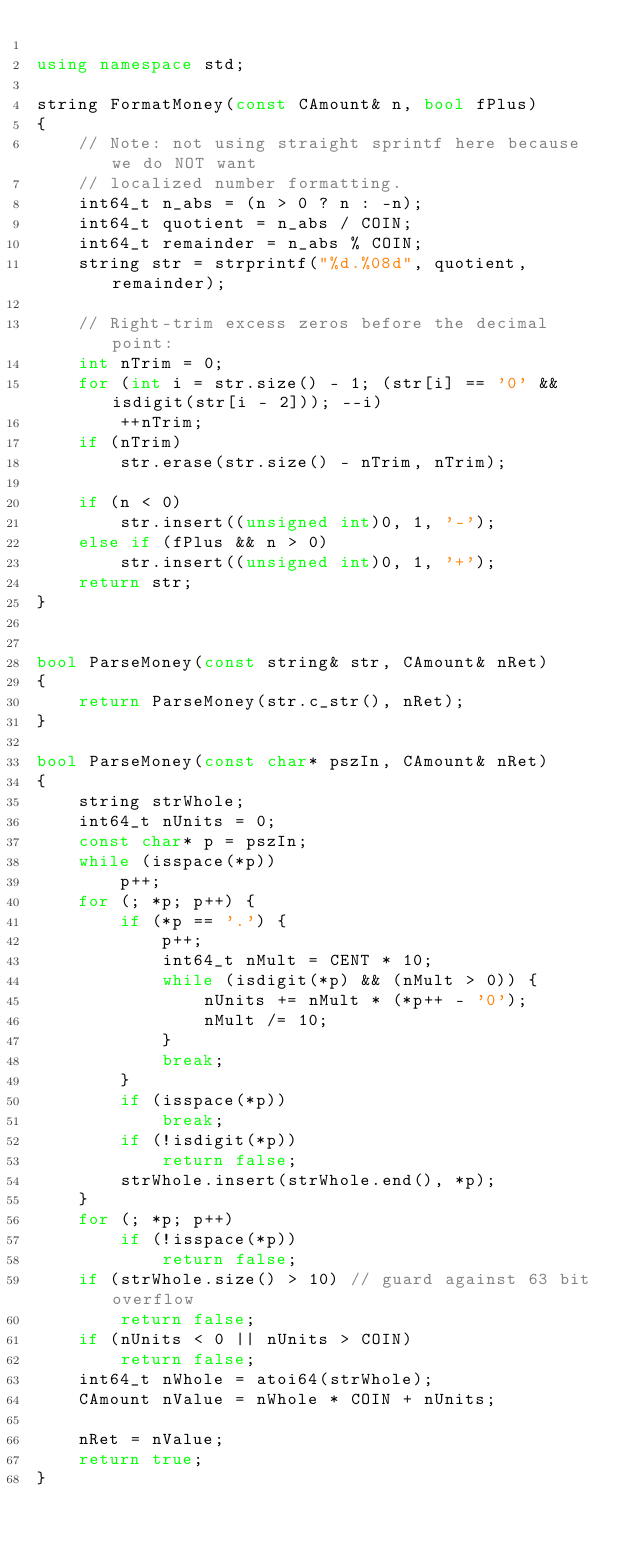<code> <loc_0><loc_0><loc_500><loc_500><_C++_>
using namespace std;

string FormatMoney(const CAmount& n, bool fPlus)
{
    // Note: not using straight sprintf here because we do NOT want
    // localized number formatting.
    int64_t n_abs = (n > 0 ? n : -n);
    int64_t quotient = n_abs / COIN;
    int64_t remainder = n_abs % COIN;
    string str = strprintf("%d.%08d", quotient, remainder);

    // Right-trim excess zeros before the decimal point:
    int nTrim = 0;
    for (int i = str.size() - 1; (str[i] == '0' && isdigit(str[i - 2])); --i)
        ++nTrim;
    if (nTrim)
        str.erase(str.size() - nTrim, nTrim);

    if (n < 0)
        str.insert((unsigned int)0, 1, '-');
    else if (fPlus && n > 0)
        str.insert((unsigned int)0, 1, '+');
    return str;
}


bool ParseMoney(const string& str, CAmount& nRet)
{
    return ParseMoney(str.c_str(), nRet);
}

bool ParseMoney(const char* pszIn, CAmount& nRet)
{
    string strWhole;
    int64_t nUnits = 0;
    const char* p = pszIn;
    while (isspace(*p))
        p++;
    for (; *p; p++) {
        if (*p == '.') {
            p++;
            int64_t nMult = CENT * 10;
            while (isdigit(*p) && (nMult > 0)) {
                nUnits += nMult * (*p++ - '0');
                nMult /= 10;
            }
            break;
        }
        if (isspace(*p))
            break;
        if (!isdigit(*p))
            return false;
        strWhole.insert(strWhole.end(), *p);
    }
    for (; *p; p++)
        if (!isspace(*p))
            return false;
    if (strWhole.size() > 10) // guard against 63 bit overflow
        return false;
    if (nUnits < 0 || nUnits > COIN)
        return false;
    int64_t nWhole = atoi64(strWhole);
    CAmount nValue = nWhole * COIN + nUnits;

    nRet = nValue;
    return true;
}
</code> 